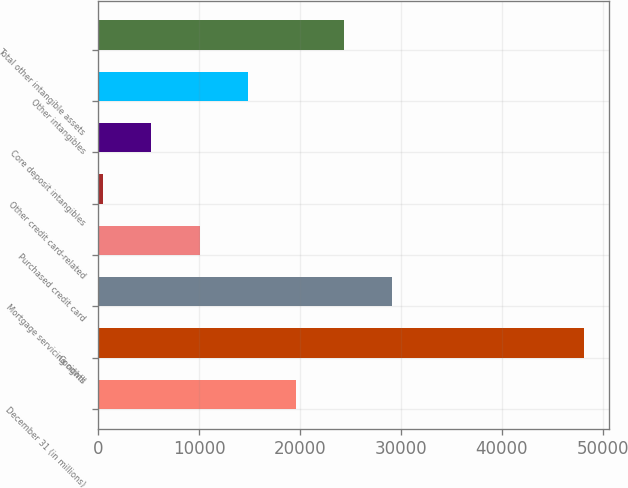Convert chart. <chart><loc_0><loc_0><loc_500><loc_500><bar_chart><fcel>December 31 (in millions)<fcel>Goodwill<fcel>Mortgage servicing rights<fcel>Purchased credit card<fcel>Other credit card-related<fcel>Core deposit intangibles<fcel>Other intangibles<fcel>Total other intangible assets<nl><fcel>19568<fcel>48188<fcel>29108<fcel>10028<fcel>488<fcel>5258<fcel>14798<fcel>24338<nl></chart> 